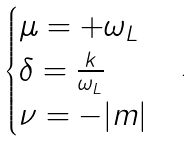<formula> <loc_0><loc_0><loc_500><loc_500>\begin{cases} \mu = + \omega _ { L } \\ \delta = \frac { k } { \omega _ { L } } \\ \nu = - | m | \end{cases} .</formula> 